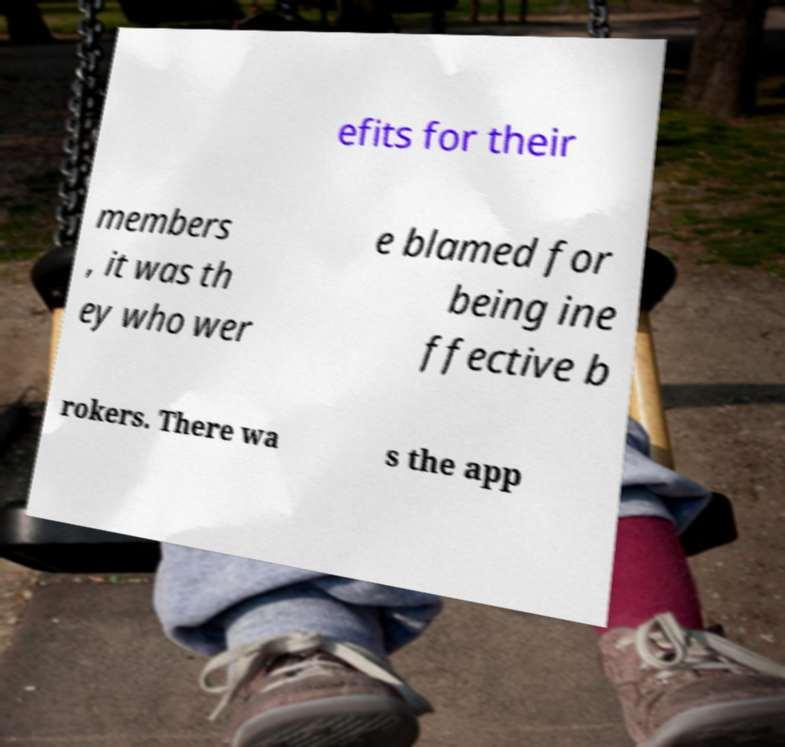What messages or text are displayed in this image? I need them in a readable, typed format. efits for their members , it was th ey who wer e blamed for being ine ffective b rokers. There wa s the app 